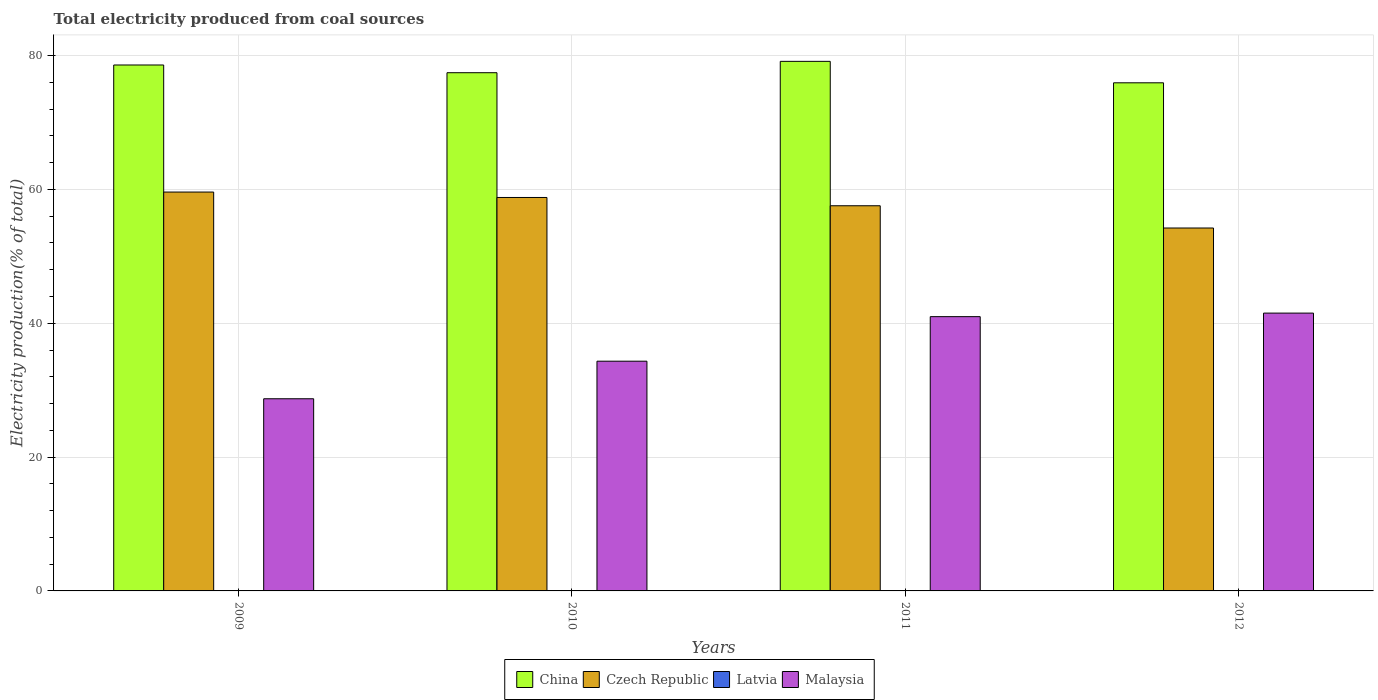How many different coloured bars are there?
Offer a very short reply. 4. How many bars are there on the 1st tick from the left?
Provide a succinct answer. 4. What is the label of the 3rd group of bars from the left?
Provide a succinct answer. 2011. What is the total electricity produced in Latvia in 2011?
Your answer should be very brief. 0.03. Across all years, what is the maximum total electricity produced in China?
Offer a very short reply. 79.14. Across all years, what is the minimum total electricity produced in Latvia?
Make the answer very short. 0.03. In which year was the total electricity produced in Czech Republic maximum?
Your response must be concise. 2009. What is the total total electricity produced in Malaysia in the graph?
Your answer should be compact. 145.54. What is the difference between the total electricity produced in China in 2009 and that in 2010?
Your response must be concise. 1.15. What is the difference between the total electricity produced in Malaysia in 2010 and the total electricity produced in Latvia in 2012?
Your response must be concise. 34.3. What is the average total electricity produced in Czech Republic per year?
Give a very brief answer. 57.55. In the year 2009, what is the difference between the total electricity produced in Malaysia and total electricity produced in Latvia?
Provide a short and direct response. 28.68. What is the ratio of the total electricity produced in Latvia in 2009 to that in 2010?
Your response must be concise. 1.19. What is the difference between the highest and the second highest total electricity produced in Czech Republic?
Your answer should be very brief. 0.81. What is the difference between the highest and the lowest total electricity produced in Latvia?
Keep it short and to the point. 0.01. In how many years, is the total electricity produced in Latvia greater than the average total electricity produced in Latvia taken over all years?
Make the answer very short. 1. Is the sum of the total electricity produced in Latvia in 2010 and 2012 greater than the maximum total electricity produced in Malaysia across all years?
Give a very brief answer. No. What does the 3rd bar from the right in 2011 represents?
Make the answer very short. Czech Republic. How many bars are there?
Give a very brief answer. 16. How many years are there in the graph?
Provide a succinct answer. 4. Are the values on the major ticks of Y-axis written in scientific E-notation?
Give a very brief answer. No. What is the title of the graph?
Provide a short and direct response. Total electricity produced from coal sources. Does "Colombia" appear as one of the legend labels in the graph?
Make the answer very short. No. What is the label or title of the Y-axis?
Your answer should be very brief. Electricity production(% of total). What is the Electricity production(% of total) in China in 2009?
Provide a succinct answer. 78.59. What is the Electricity production(% of total) in Czech Republic in 2009?
Ensure brevity in your answer.  59.6. What is the Electricity production(% of total) in Latvia in 2009?
Provide a short and direct response. 0.04. What is the Electricity production(% of total) of Malaysia in 2009?
Offer a very short reply. 28.71. What is the Electricity production(% of total) in China in 2010?
Ensure brevity in your answer.  77.44. What is the Electricity production(% of total) of Czech Republic in 2010?
Your response must be concise. 58.79. What is the Electricity production(% of total) of Latvia in 2010?
Provide a short and direct response. 0.03. What is the Electricity production(% of total) in Malaysia in 2010?
Offer a terse response. 34.33. What is the Electricity production(% of total) of China in 2011?
Your answer should be compact. 79.14. What is the Electricity production(% of total) in Czech Republic in 2011?
Your response must be concise. 57.56. What is the Electricity production(% of total) of Latvia in 2011?
Provide a short and direct response. 0.03. What is the Electricity production(% of total) of Malaysia in 2011?
Your answer should be compact. 40.99. What is the Electricity production(% of total) of China in 2012?
Your response must be concise. 75.93. What is the Electricity production(% of total) in Czech Republic in 2012?
Keep it short and to the point. 54.23. What is the Electricity production(% of total) of Latvia in 2012?
Offer a terse response. 0.03. What is the Electricity production(% of total) of Malaysia in 2012?
Your answer should be compact. 41.51. Across all years, what is the maximum Electricity production(% of total) of China?
Your answer should be compact. 79.14. Across all years, what is the maximum Electricity production(% of total) in Czech Republic?
Provide a short and direct response. 59.6. Across all years, what is the maximum Electricity production(% of total) of Latvia?
Offer a very short reply. 0.04. Across all years, what is the maximum Electricity production(% of total) of Malaysia?
Ensure brevity in your answer.  41.51. Across all years, what is the minimum Electricity production(% of total) of China?
Keep it short and to the point. 75.93. Across all years, what is the minimum Electricity production(% of total) in Czech Republic?
Offer a terse response. 54.23. Across all years, what is the minimum Electricity production(% of total) in Latvia?
Provide a short and direct response. 0.03. Across all years, what is the minimum Electricity production(% of total) in Malaysia?
Make the answer very short. 28.71. What is the total Electricity production(% of total) in China in the graph?
Give a very brief answer. 311.1. What is the total Electricity production(% of total) in Czech Republic in the graph?
Make the answer very short. 230.19. What is the total Electricity production(% of total) of Latvia in the graph?
Ensure brevity in your answer.  0.13. What is the total Electricity production(% of total) of Malaysia in the graph?
Provide a succinct answer. 145.54. What is the difference between the Electricity production(% of total) in China in 2009 and that in 2010?
Your answer should be very brief. 1.15. What is the difference between the Electricity production(% of total) in Czech Republic in 2009 and that in 2010?
Provide a succinct answer. 0.81. What is the difference between the Electricity production(% of total) in Latvia in 2009 and that in 2010?
Your response must be concise. 0.01. What is the difference between the Electricity production(% of total) in Malaysia in 2009 and that in 2010?
Provide a succinct answer. -5.62. What is the difference between the Electricity production(% of total) of China in 2009 and that in 2011?
Give a very brief answer. -0.54. What is the difference between the Electricity production(% of total) of Czech Republic in 2009 and that in 2011?
Make the answer very short. 2.05. What is the difference between the Electricity production(% of total) of Latvia in 2009 and that in 2011?
Provide a short and direct response. 0. What is the difference between the Electricity production(% of total) in Malaysia in 2009 and that in 2011?
Ensure brevity in your answer.  -12.27. What is the difference between the Electricity production(% of total) in China in 2009 and that in 2012?
Keep it short and to the point. 2.66. What is the difference between the Electricity production(% of total) of Czech Republic in 2009 and that in 2012?
Provide a short and direct response. 5.37. What is the difference between the Electricity production(% of total) of Latvia in 2009 and that in 2012?
Keep it short and to the point. 0. What is the difference between the Electricity production(% of total) of Malaysia in 2009 and that in 2012?
Ensure brevity in your answer.  -12.8. What is the difference between the Electricity production(% of total) in China in 2010 and that in 2011?
Offer a very short reply. -1.7. What is the difference between the Electricity production(% of total) of Czech Republic in 2010 and that in 2011?
Make the answer very short. 1.24. What is the difference between the Electricity production(% of total) in Latvia in 2010 and that in 2011?
Your answer should be very brief. -0. What is the difference between the Electricity production(% of total) in Malaysia in 2010 and that in 2011?
Make the answer very short. -6.66. What is the difference between the Electricity production(% of total) in China in 2010 and that in 2012?
Provide a short and direct response. 1.51. What is the difference between the Electricity production(% of total) in Czech Republic in 2010 and that in 2012?
Keep it short and to the point. 4.56. What is the difference between the Electricity production(% of total) of Latvia in 2010 and that in 2012?
Offer a very short reply. -0. What is the difference between the Electricity production(% of total) in Malaysia in 2010 and that in 2012?
Your response must be concise. -7.18. What is the difference between the Electricity production(% of total) of China in 2011 and that in 2012?
Provide a succinct answer. 3.21. What is the difference between the Electricity production(% of total) in Czech Republic in 2011 and that in 2012?
Ensure brevity in your answer.  3.33. What is the difference between the Electricity production(% of total) of Latvia in 2011 and that in 2012?
Ensure brevity in your answer.  0. What is the difference between the Electricity production(% of total) of Malaysia in 2011 and that in 2012?
Your response must be concise. -0.53. What is the difference between the Electricity production(% of total) of China in 2009 and the Electricity production(% of total) of Czech Republic in 2010?
Keep it short and to the point. 19.8. What is the difference between the Electricity production(% of total) of China in 2009 and the Electricity production(% of total) of Latvia in 2010?
Offer a very short reply. 78.56. What is the difference between the Electricity production(% of total) in China in 2009 and the Electricity production(% of total) in Malaysia in 2010?
Provide a short and direct response. 44.26. What is the difference between the Electricity production(% of total) of Czech Republic in 2009 and the Electricity production(% of total) of Latvia in 2010?
Your answer should be compact. 59.57. What is the difference between the Electricity production(% of total) of Czech Republic in 2009 and the Electricity production(% of total) of Malaysia in 2010?
Your answer should be very brief. 25.27. What is the difference between the Electricity production(% of total) in Latvia in 2009 and the Electricity production(% of total) in Malaysia in 2010?
Provide a succinct answer. -34.29. What is the difference between the Electricity production(% of total) in China in 2009 and the Electricity production(% of total) in Czech Republic in 2011?
Your response must be concise. 21.03. What is the difference between the Electricity production(% of total) in China in 2009 and the Electricity production(% of total) in Latvia in 2011?
Your answer should be compact. 78.56. What is the difference between the Electricity production(% of total) in China in 2009 and the Electricity production(% of total) in Malaysia in 2011?
Offer a terse response. 37.61. What is the difference between the Electricity production(% of total) of Czech Republic in 2009 and the Electricity production(% of total) of Latvia in 2011?
Provide a short and direct response. 59.57. What is the difference between the Electricity production(% of total) of Czech Republic in 2009 and the Electricity production(% of total) of Malaysia in 2011?
Offer a very short reply. 18.62. What is the difference between the Electricity production(% of total) in Latvia in 2009 and the Electricity production(% of total) in Malaysia in 2011?
Offer a very short reply. -40.95. What is the difference between the Electricity production(% of total) in China in 2009 and the Electricity production(% of total) in Czech Republic in 2012?
Offer a terse response. 24.36. What is the difference between the Electricity production(% of total) of China in 2009 and the Electricity production(% of total) of Latvia in 2012?
Your response must be concise. 78.56. What is the difference between the Electricity production(% of total) in China in 2009 and the Electricity production(% of total) in Malaysia in 2012?
Give a very brief answer. 37.08. What is the difference between the Electricity production(% of total) of Czech Republic in 2009 and the Electricity production(% of total) of Latvia in 2012?
Offer a terse response. 59.57. What is the difference between the Electricity production(% of total) of Czech Republic in 2009 and the Electricity production(% of total) of Malaysia in 2012?
Provide a succinct answer. 18.09. What is the difference between the Electricity production(% of total) of Latvia in 2009 and the Electricity production(% of total) of Malaysia in 2012?
Your answer should be compact. -41.48. What is the difference between the Electricity production(% of total) of China in 2010 and the Electricity production(% of total) of Czech Republic in 2011?
Provide a succinct answer. 19.88. What is the difference between the Electricity production(% of total) in China in 2010 and the Electricity production(% of total) in Latvia in 2011?
Ensure brevity in your answer.  77.41. What is the difference between the Electricity production(% of total) of China in 2010 and the Electricity production(% of total) of Malaysia in 2011?
Give a very brief answer. 36.45. What is the difference between the Electricity production(% of total) in Czech Republic in 2010 and the Electricity production(% of total) in Latvia in 2011?
Make the answer very short. 58.76. What is the difference between the Electricity production(% of total) of Czech Republic in 2010 and the Electricity production(% of total) of Malaysia in 2011?
Make the answer very short. 17.81. What is the difference between the Electricity production(% of total) of Latvia in 2010 and the Electricity production(% of total) of Malaysia in 2011?
Offer a terse response. -40.95. What is the difference between the Electricity production(% of total) in China in 2010 and the Electricity production(% of total) in Czech Republic in 2012?
Give a very brief answer. 23.21. What is the difference between the Electricity production(% of total) in China in 2010 and the Electricity production(% of total) in Latvia in 2012?
Offer a terse response. 77.41. What is the difference between the Electricity production(% of total) in China in 2010 and the Electricity production(% of total) in Malaysia in 2012?
Your answer should be compact. 35.92. What is the difference between the Electricity production(% of total) of Czech Republic in 2010 and the Electricity production(% of total) of Latvia in 2012?
Provide a short and direct response. 58.76. What is the difference between the Electricity production(% of total) of Czech Republic in 2010 and the Electricity production(% of total) of Malaysia in 2012?
Ensure brevity in your answer.  17.28. What is the difference between the Electricity production(% of total) of Latvia in 2010 and the Electricity production(% of total) of Malaysia in 2012?
Ensure brevity in your answer.  -41.48. What is the difference between the Electricity production(% of total) of China in 2011 and the Electricity production(% of total) of Czech Republic in 2012?
Your answer should be compact. 24.91. What is the difference between the Electricity production(% of total) of China in 2011 and the Electricity production(% of total) of Latvia in 2012?
Keep it short and to the point. 79.1. What is the difference between the Electricity production(% of total) of China in 2011 and the Electricity production(% of total) of Malaysia in 2012?
Ensure brevity in your answer.  37.62. What is the difference between the Electricity production(% of total) in Czech Republic in 2011 and the Electricity production(% of total) in Latvia in 2012?
Your answer should be compact. 57.52. What is the difference between the Electricity production(% of total) of Czech Republic in 2011 and the Electricity production(% of total) of Malaysia in 2012?
Offer a very short reply. 16.04. What is the difference between the Electricity production(% of total) of Latvia in 2011 and the Electricity production(% of total) of Malaysia in 2012?
Ensure brevity in your answer.  -41.48. What is the average Electricity production(% of total) of China per year?
Keep it short and to the point. 77.77. What is the average Electricity production(% of total) in Czech Republic per year?
Provide a succinct answer. 57.55. What is the average Electricity production(% of total) of Latvia per year?
Provide a succinct answer. 0.03. What is the average Electricity production(% of total) in Malaysia per year?
Provide a succinct answer. 36.39. In the year 2009, what is the difference between the Electricity production(% of total) of China and Electricity production(% of total) of Czech Republic?
Offer a very short reply. 18.99. In the year 2009, what is the difference between the Electricity production(% of total) in China and Electricity production(% of total) in Latvia?
Provide a succinct answer. 78.56. In the year 2009, what is the difference between the Electricity production(% of total) of China and Electricity production(% of total) of Malaysia?
Provide a short and direct response. 49.88. In the year 2009, what is the difference between the Electricity production(% of total) in Czech Republic and Electricity production(% of total) in Latvia?
Provide a succinct answer. 59.57. In the year 2009, what is the difference between the Electricity production(% of total) in Czech Republic and Electricity production(% of total) in Malaysia?
Offer a very short reply. 30.89. In the year 2009, what is the difference between the Electricity production(% of total) of Latvia and Electricity production(% of total) of Malaysia?
Offer a terse response. -28.68. In the year 2010, what is the difference between the Electricity production(% of total) in China and Electricity production(% of total) in Czech Republic?
Give a very brief answer. 18.65. In the year 2010, what is the difference between the Electricity production(% of total) in China and Electricity production(% of total) in Latvia?
Your answer should be compact. 77.41. In the year 2010, what is the difference between the Electricity production(% of total) of China and Electricity production(% of total) of Malaysia?
Provide a short and direct response. 43.11. In the year 2010, what is the difference between the Electricity production(% of total) in Czech Republic and Electricity production(% of total) in Latvia?
Give a very brief answer. 58.76. In the year 2010, what is the difference between the Electricity production(% of total) in Czech Republic and Electricity production(% of total) in Malaysia?
Ensure brevity in your answer.  24.46. In the year 2010, what is the difference between the Electricity production(% of total) in Latvia and Electricity production(% of total) in Malaysia?
Make the answer very short. -34.3. In the year 2011, what is the difference between the Electricity production(% of total) in China and Electricity production(% of total) in Czech Republic?
Give a very brief answer. 21.58. In the year 2011, what is the difference between the Electricity production(% of total) in China and Electricity production(% of total) in Latvia?
Provide a succinct answer. 79.1. In the year 2011, what is the difference between the Electricity production(% of total) of China and Electricity production(% of total) of Malaysia?
Provide a succinct answer. 38.15. In the year 2011, what is the difference between the Electricity production(% of total) in Czech Republic and Electricity production(% of total) in Latvia?
Make the answer very short. 57.52. In the year 2011, what is the difference between the Electricity production(% of total) of Czech Republic and Electricity production(% of total) of Malaysia?
Your response must be concise. 16.57. In the year 2011, what is the difference between the Electricity production(% of total) in Latvia and Electricity production(% of total) in Malaysia?
Give a very brief answer. -40.95. In the year 2012, what is the difference between the Electricity production(% of total) of China and Electricity production(% of total) of Czech Republic?
Your response must be concise. 21.7. In the year 2012, what is the difference between the Electricity production(% of total) in China and Electricity production(% of total) in Latvia?
Make the answer very short. 75.9. In the year 2012, what is the difference between the Electricity production(% of total) of China and Electricity production(% of total) of Malaysia?
Your response must be concise. 34.42. In the year 2012, what is the difference between the Electricity production(% of total) of Czech Republic and Electricity production(% of total) of Latvia?
Offer a terse response. 54.2. In the year 2012, what is the difference between the Electricity production(% of total) of Czech Republic and Electricity production(% of total) of Malaysia?
Your answer should be compact. 12.72. In the year 2012, what is the difference between the Electricity production(% of total) of Latvia and Electricity production(% of total) of Malaysia?
Offer a very short reply. -41.48. What is the ratio of the Electricity production(% of total) in China in 2009 to that in 2010?
Your answer should be very brief. 1.01. What is the ratio of the Electricity production(% of total) of Czech Republic in 2009 to that in 2010?
Your response must be concise. 1.01. What is the ratio of the Electricity production(% of total) in Latvia in 2009 to that in 2010?
Offer a very short reply. 1.19. What is the ratio of the Electricity production(% of total) in Malaysia in 2009 to that in 2010?
Your answer should be very brief. 0.84. What is the ratio of the Electricity production(% of total) in Czech Republic in 2009 to that in 2011?
Your answer should be very brief. 1.04. What is the ratio of the Electricity production(% of total) in Latvia in 2009 to that in 2011?
Give a very brief answer. 1.09. What is the ratio of the Electricity production(% of total) of Malaysia in 2009 to that in 2011?
Provide a short and direct response. 0.7. What is the ratio of the Electricity production(% of total) in China in 2009 to that in 2012?
Your response must be concise. 1.03. What is the ratio of the Electricity production(% of total) of Czech Republic in 2009 to that in 2012?
Keep it short and to the point. 1.1. What is the ratio of the Electricity production(% of total) of Latvia in 2009 to that in 2012?
Provide a short and direct response. 1.11. What is the ratio of the Electricity production(% of total) of Malaysia in 2009 to that in 2012?
Provide a short and direct response. 0.69. What is the ratio of the Electricity production(% of total) in China in 2010 to that in 2011?
Offer a very short reply. 0.98. What is the ratio of the Electricity production(% of total) of Czech Republic in 2010 to that in 2011?
Your answer should be compact. 1.02. What is the ratio of the Electricity production(% of total) in Latvia in 2010 to that in 2011?
Provide a short and direct response. 0.92. What is the ratio of the Electricity production(% of total) in Malaysia in 2010 to that in 2011?
Provide a succinct answer. 0.84. What is the ratio of the Electricity production(% of total) of China in 2010 to that in 2012?
Give a very brief answer. 1.02. What is the ratio of the Electricity production(% of total) of Czech Republic in 2010 to that in 2012?
Offer a very short reply. 1.08. What is the ratio of the Electricity production(% of total) of Latvia in 2010 to that in 2012?
Provide a short and direct response. 0.93. What is the ratio of the Electricity production(% of total) in Malaysia in 2010 to that in 2012?
Provide a short and direct response. 0.83. What is the ratio of the Electricity production(% of total) in China in 2011 to that in 2012?
Provide a short and direct response. 1.04. What is the ratio of the Electricity production(% of total) of Czech Republic in 2011 to that in 2012?
Offer a terse response. 1.06. What is the ratio of the Electricity production(% of total) in Malaysia in 2011 to that in 2012?
Provide a succinct answer. 0.99. What is the difference between the highest and the second highest Electricity production(% of total) in China?
Ensure brevity in your answer.  0.54. What is the difference between the highest and the second highest Electricity production(% of total) in Czech Republic?
Your answer should be very brief. 0.81. What is the difference between the highest and the second highest Electricity production(% of total) of Latvia?
Provide a short and direct response. 0. What is the difference between the highest and the second highest Electricity production(% of total) of Malaysia?
Your answer should be compact. 0.53. What is the difference between the highest and the lowest Electricity production(% of total) of China?
Provide a short and direct response. 3.21. What is the difference between the highest and the lowest Electricity production(% of total) in Czech Republic?
Offer a terse response. 5.37. What is the difference between the highest and the lowest Electricity production(% of total) of Latvia?
Your answer should be compact. 0.01. What is the difference between the highest and the lowest Electricity production(% of total) in Malaysia?
Ensure brevity in your answer.  12.8. 